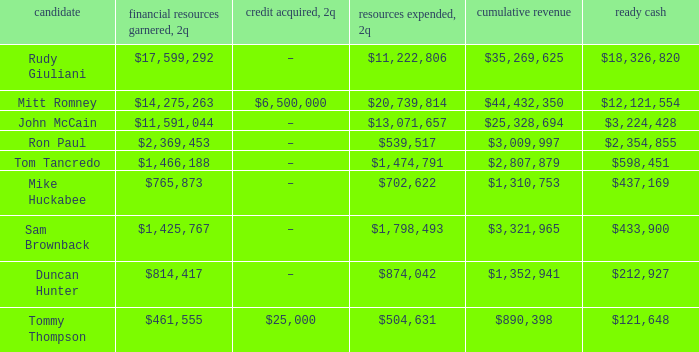What is the total money raised when the 2q spending occurs and the value of 2q is $874,042? $814,417. 